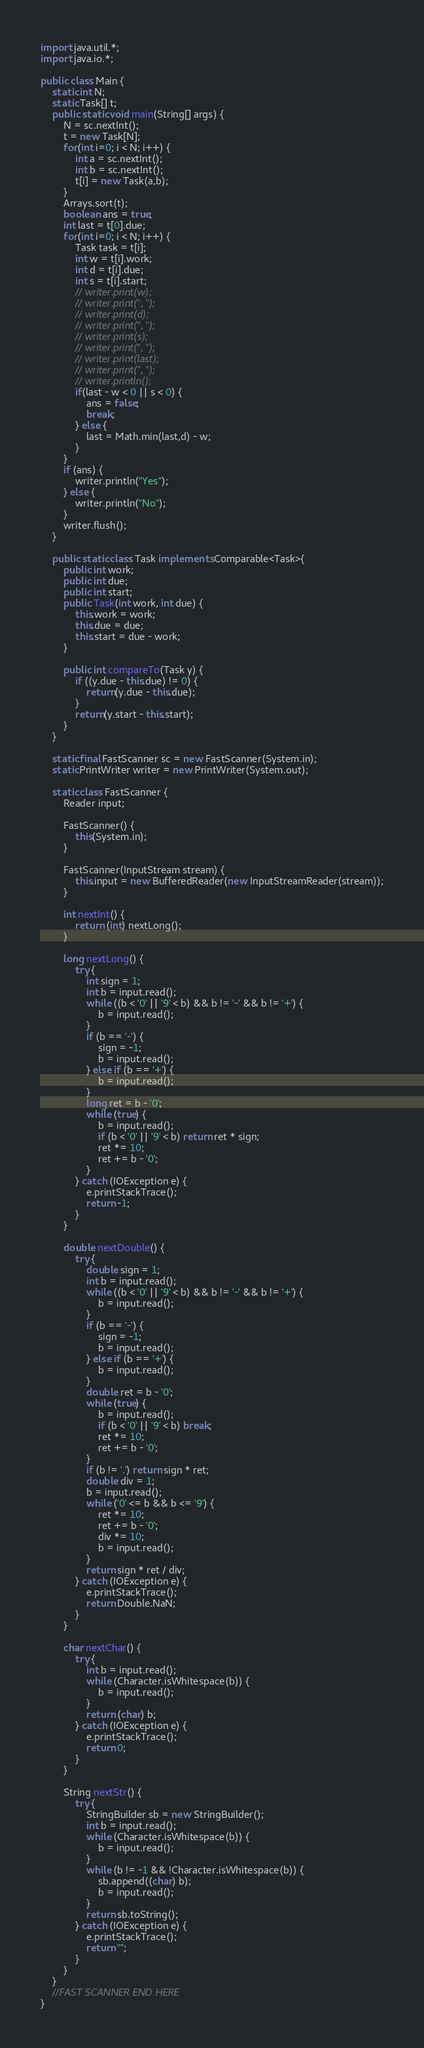<code> <loc_0><loc_0><loc_500><loc_500><_Java_>import java.util.*;
import java.io.*;

public class Main {
    static int N;
    static Task[] t;
    public static void main(String[] args) {
        N = sc.nextInt();
        t = new Task[N];
        for(int i=0; i < N; i++) {
            int a = sc.nextInt();
            int b = sc.nextInt();
            t[i] = new Task(a,b);
        }
        Arrays.sort(t);
        boolean ans = true;
        int last = t[0].due;
        for(int i=0; i < N; i++) {
            Task task = t[i];
            int w = t[i].work;
            int d = t[i].due;
            int s = t[i].start;
            // writer.print(w);
            // writer.print(", ");
            // writer.print(d);
            // writer.print(", ");
            // writer.print(s);
            // writer.print(", ");
            // writer.print(last);
            // writer.print(", ");
            // writer.println();
            if(last - w < 0 || s < 0) {
                ans = false;
                break;
            } else {
                last = Math.min(last,d) - w;
            }
        }
        if (ans) {
            writer.println("Yes");
        } else {
            writer.println("No");
        }
        writer.flush();
    }

    public static class Task implements Comparable<Task>{
        public int work;
        public int due;
        public int start;
        public Task(int work, int due) {
            this.work = work;
            this.due = due;
            this.start = due - work;
        }

        public int compareTo(Task y) {
            if ((y.due - this.due) != 0) {
                return(y.due - this.due);
            }
            return(y.start - this.start);
        }
    }

    static final FastScanner sc = new FastScanner(System.in);
    static PrintWriter writer = new PrintWriter(System.out);

    static class FastScanner {
        Reader input;
 
        FastScanner() {
            this(System.in);
        }
 
        FastScanner(InputStream stream) {
            this.input = new BufferedReader(new InputStreamReader(stream));
        }
 
        int nextInt() {
            return (int) nextLong();
        }
 
        long nextLong() {
            try {
                int sign = 1;
                int b = input.read();
                while ((b < '0' || '9' < b) && b != '-' && b != '+') {
                    b = input.read();
                }
                if (b == '-') {
                    sign = -1;
                    b = input.read();
                } else if (b == '+') {
                    b = input.read();
                }
                long ret = b - '0';
                while (true) {
                    b = input.read();
                    if (b < '0' || '9' < b) return ret * sign;
                    ret *= 10;
                    ret += b - '0';
                }
            } catch (IOException e) {
                e.printStackTrace();
                return -1;
            }
        }
 
        double nextDouble() {
            try {
                double sign = 1;
                int b = input.read();
                while ((b < '0' || '9' < b) && b != '-' && b != '+') {
                    b = input.read();
                }
                if (b == '-') {
                    sign = -1;
                    b = input.read();
                } else if (b == '+') {
                    b = input.read();
                }
                double ret = b - '0';
                while (true) {
                    b = input.read();
                    if (b < '0' || '9' < b) break;
                    ret *= 10;
                    ret += b - '0';
                }
                if (b != '.') return sign * ret;
                double div = 1;
                b = input.read();
                while ('0' <= b && b <= '9') {
                    ret *= 10;
                    ret += b - '0';
                    div *= 10;
                    b = input.read();
                }
                return sign * ret / div;
            } catch (IOException e) {
                e.printStackTrace();
                return Double.NaN;
            }
        }
 
        char nextChar() {
            try {
                int b = input.read();
                while (Character.isWhitespace(b)) {
                    b = input.read();
                }
                return (char) b;
            } catch (IOException e) {
                e.printStackTrace();
                return 0;
            }
        }
 
        String nextStr() {
            try {
                StringBuilder sb = new StringBuilder();
                int b = input.read();
                while (Character.isWhitespace(b)) {
                    b = input.read();
                }
                while (b != -1 && !Character.isWhitespace(b)) {
                    sb.append((char) b);
                    b = input.read();
                }
                return sb.toString();
            } catch (IOException e) {
                e.printStackTrace();
                return "";
            }
        }
    }
    //FAST SCANNER END HERE
}
</code> 